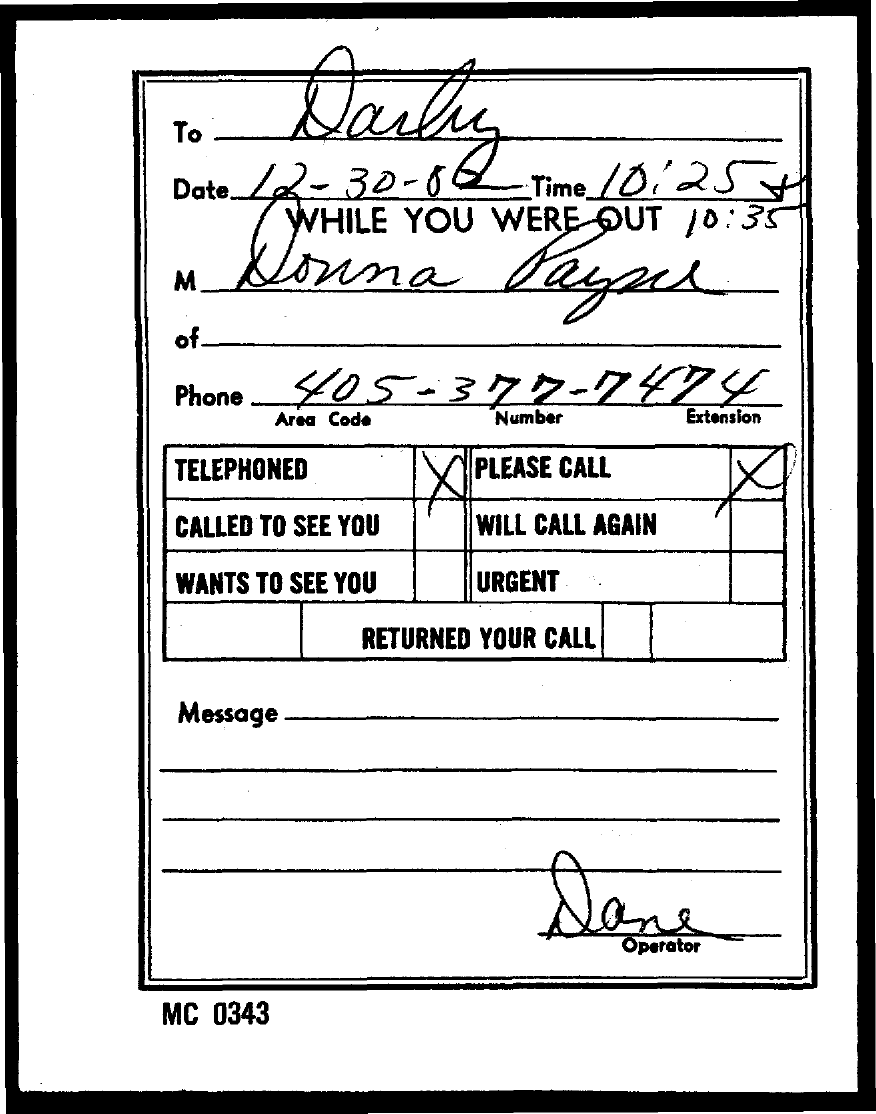Draw attention to some important aspects in this diagram. The area code is 405... The number is 377. The phone number mentioned is 405-377-7474. The CODE number mentioned on the left bottom of the page is MC 0343. The extension is a numeric code that is used to identify a specific device or software application. In the case of the message "7474...," the extension is "7474. 